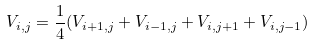Convert formula to latex. <formula><loc_0><loc_0><loc_500><loc_500>V _ { i , j } = \frac { 1 } { 4 } ( V _ { i + 1 , j } + V _ { i - 1 , j } + V _ { i , j + 1 } + V _ { i , j - 1 } )</formula> 